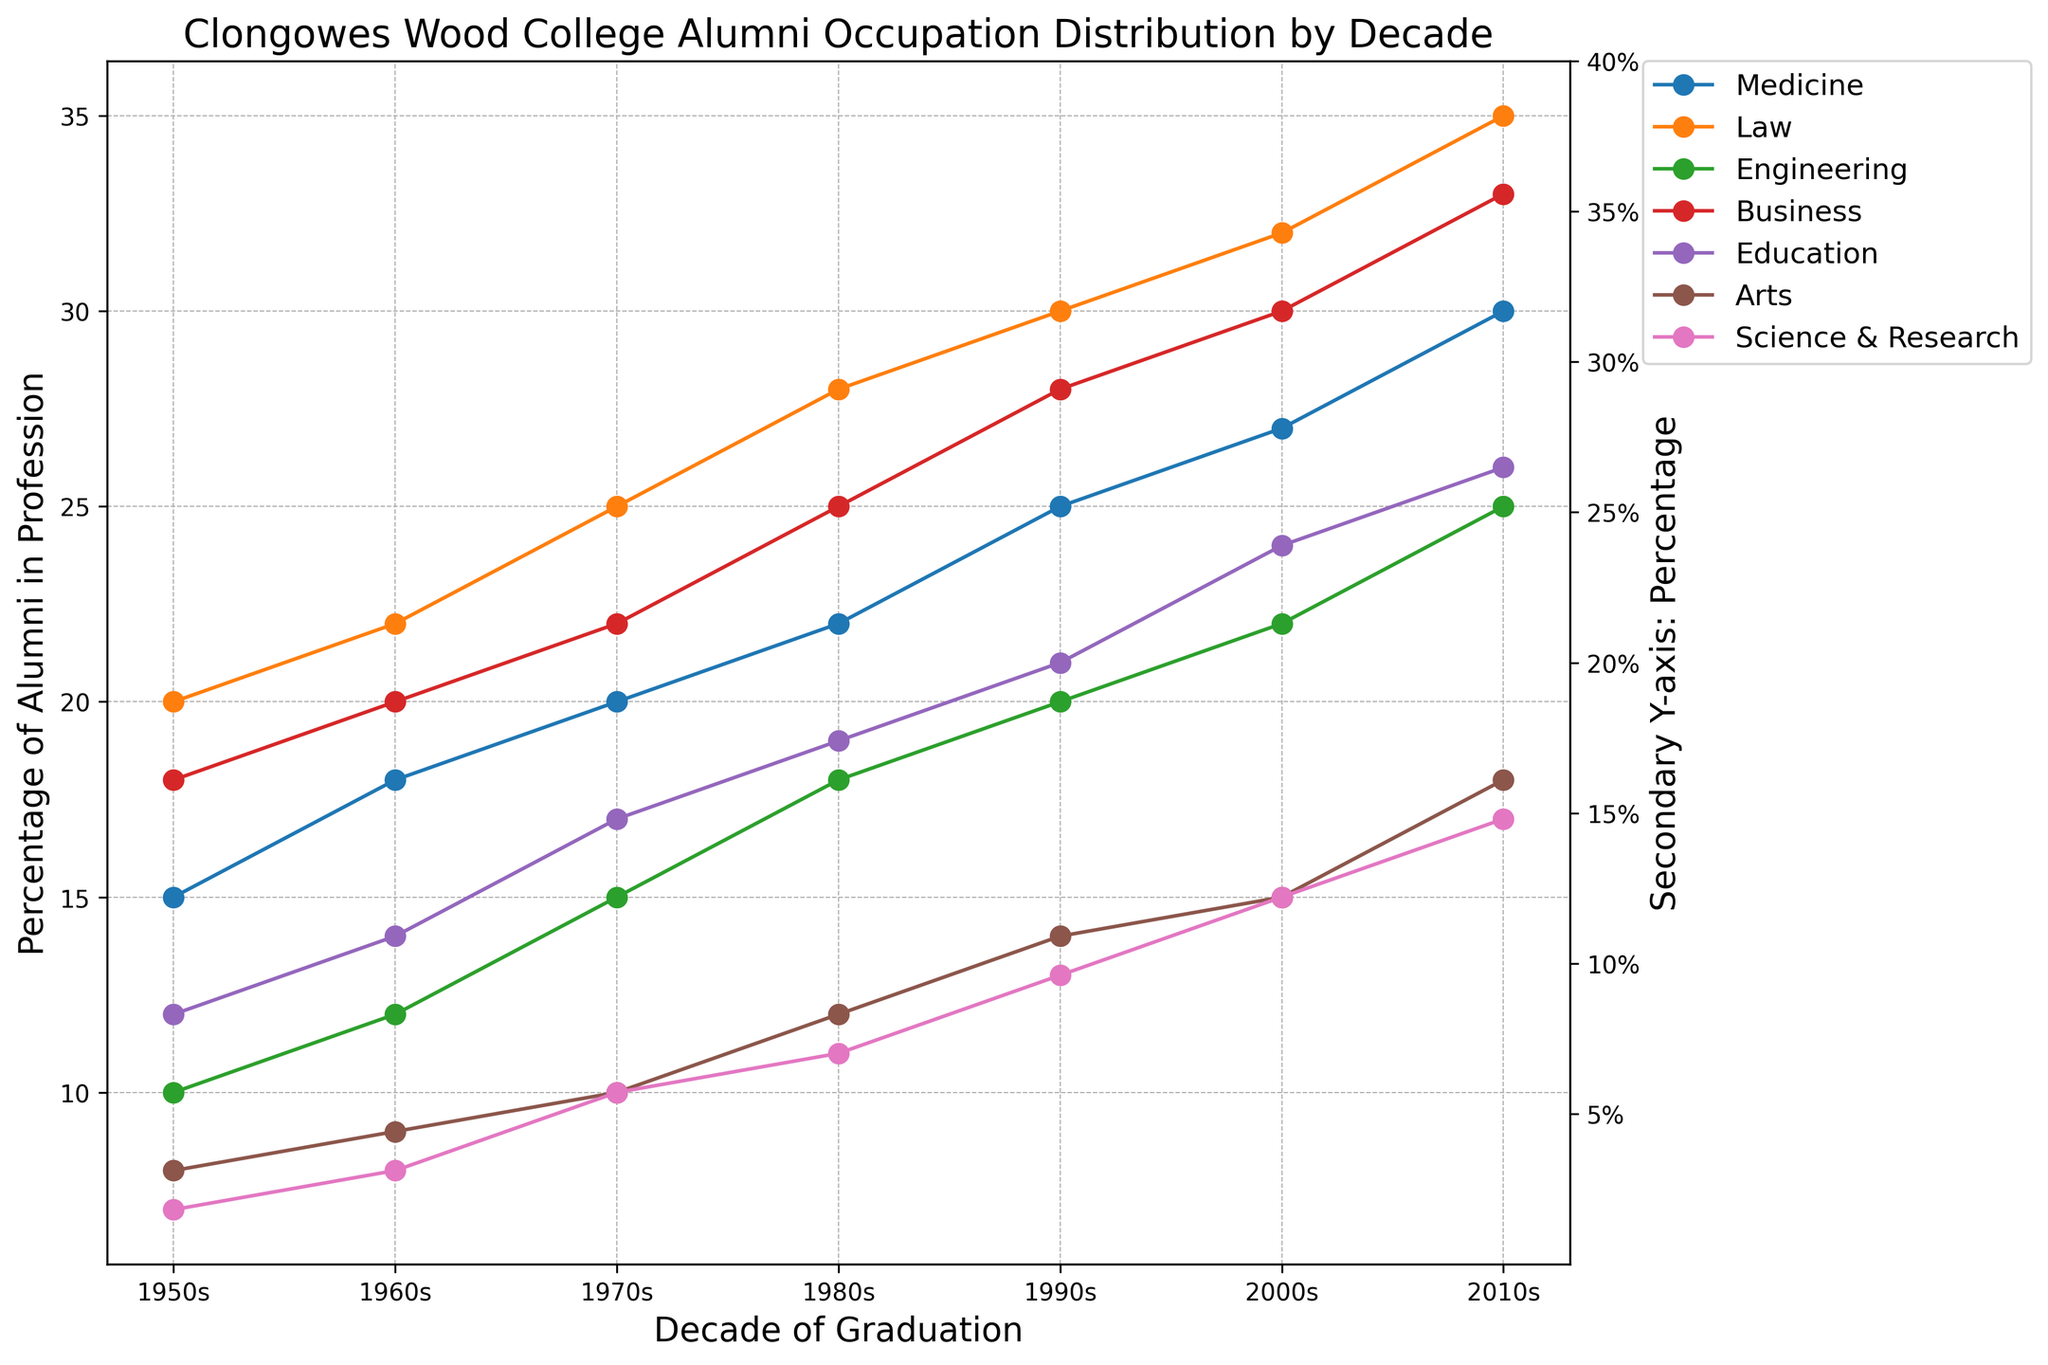What profession has the highest percentage of alumni in the 2010s? By looking at the percentage of alumni in each profession in the 2010s, the highest percentage belongs to Law with 35%.
Answer: Law Which two professions showed the greatest increase in alumni percentage from the 1950s to the 2010s? Calculate the difference between the percentages in the 2010s and the 1950s for each profession. Law increased by 15%, Business increased by 15%, indicating both have the greatest increase.
Answer: Law and Business In which decade did Engineering overtake Arts in percentage of alumni in the profession? Compare the percentages of Engineering and Arts for each decade. Engineering overtook Arts starting the 1960s with 12% compared to 9%.
Answer: 1960s What's the average percentage of alumni in the profession of Medicine over the decades? Sum the percentage values for Medicine across all decades and divide by the number of decades: (15 + 18 + 20 + 22 + 25 + 27 + 30) / 7 = 157 / 7 ≈ 22.43%.
Answer: 22.43% In which decade did the percentage of Business alumni equal Medicine alumni? Examine the trends and look for any overlaps. In the 1980s, the percentage of alumni in Business equals that in Medicine, both are 25%.
Answer: 1980s Which profession has consistently had the lowest percentage of alumni throughout the decades? Look for the profession with the lowest percentages consistently in each decade. Science & Research has the lowest percentages ranging from 7% to 17%.
Answer: Science & Research By how much did the percentage of alumni in the Education profession increase from the 1950s to the 2000s? Calculate the difference between the percentages in the 2000s and the 1950s for Education: 24% - 12% = 12%.
Answer: 12% Which decade shows the highest overall increase in percentage across all professions combined? Sum each profession's percentage for every decade then find the one with the highest sum. The 2010s have the highest combined sum of percentages (30 + 35 + 25 + 33 + 26 + 18 + 17 = 184%).
Answer: 2010s What is the difference in the percentage of alumni in the Law profession between the 1970s and the 2000s? Subtract the percentage in the 1970s from that in the 2000s for Law: 32% - 25% = 7%.
Answer: 7% Which two professions had exactly the same percentage of alumni in any decade? Find any instances where the percentages match. Both Medicine and Business had 25% in the 1980s.
Answer: Medicine and Business 